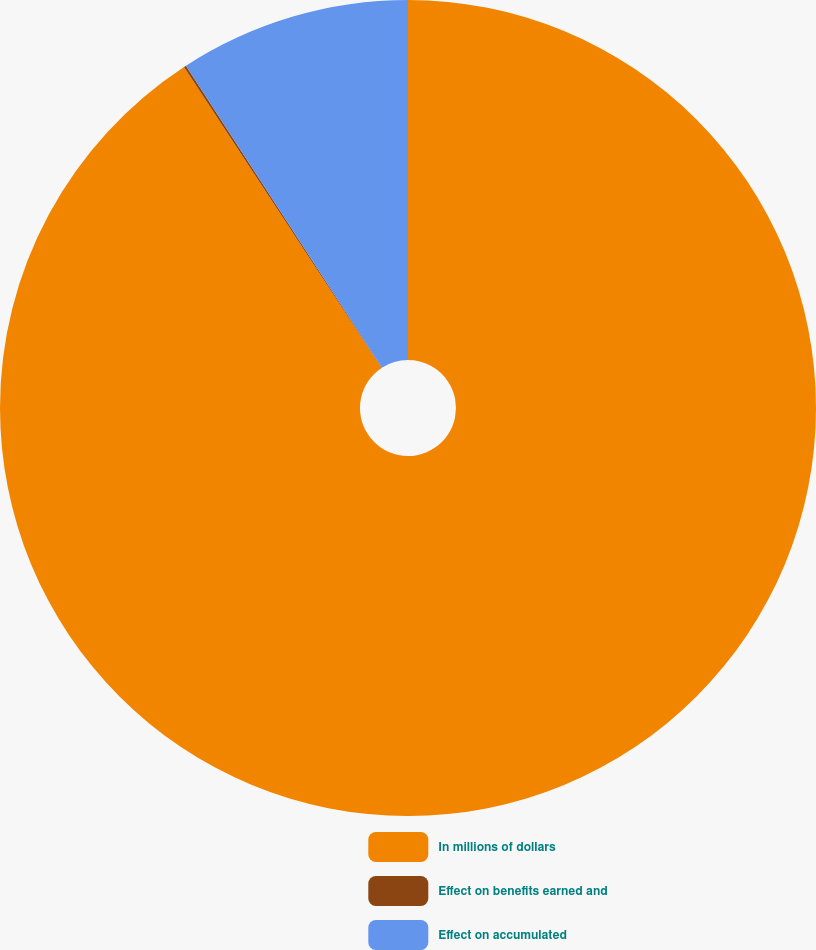<chart> <loc_0><loc_0><loc_500><loc_500><pie_chart><fcel>In millions of dollars<fcel>Effect on benefits earned and<fcel>Effect on accumulated<nl><fcel>90.75%<fcel>0.09%<fcel>9.16%<nl></chart> 